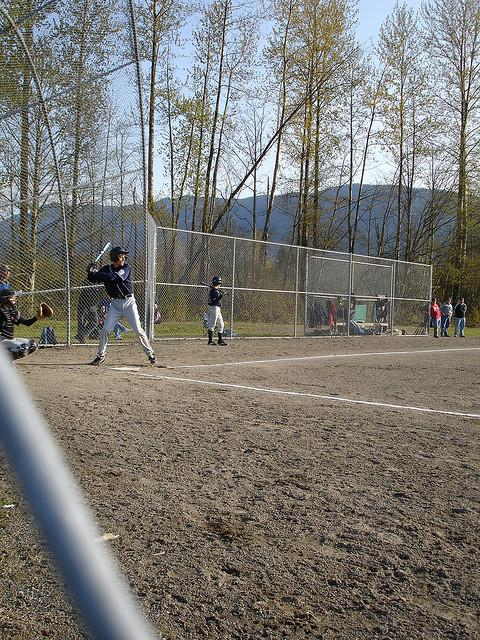What shape is the object used to play this game? Please explain your reasoning. round. In this particular sport bats are used to hit circular leather balls. 